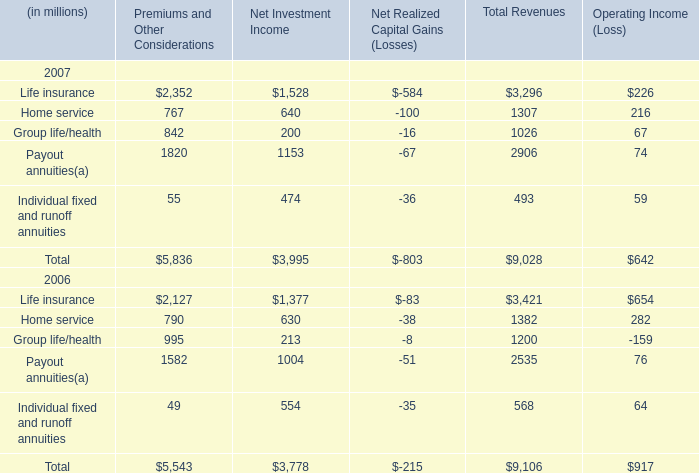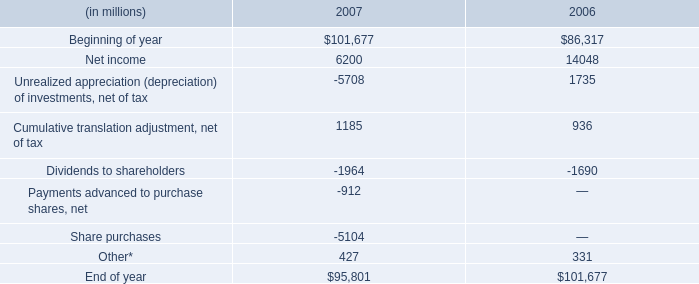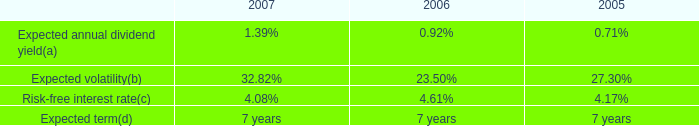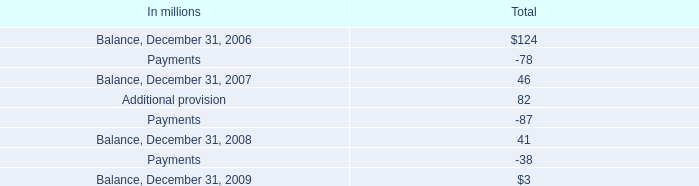In the year / section with lowest amount of Home service in Total Revenues, what's the increasing rate of Payout annuities in Total Revenues? 
Computations: ((2906 - 2535) / 2535)
Answer: 0.14635. 